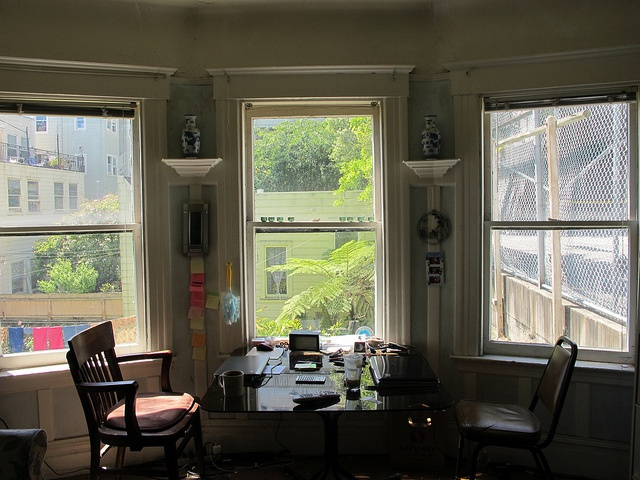Describe the objects in this image and their specific colors. I can see dining table in black, darkgray, gray, and olive tones, chair in black, maroon, and gray tones, chair in black and gray tones, couch in black and gray tones, and laptop in black, gray, darkgray, and lightgray tones in this image. 